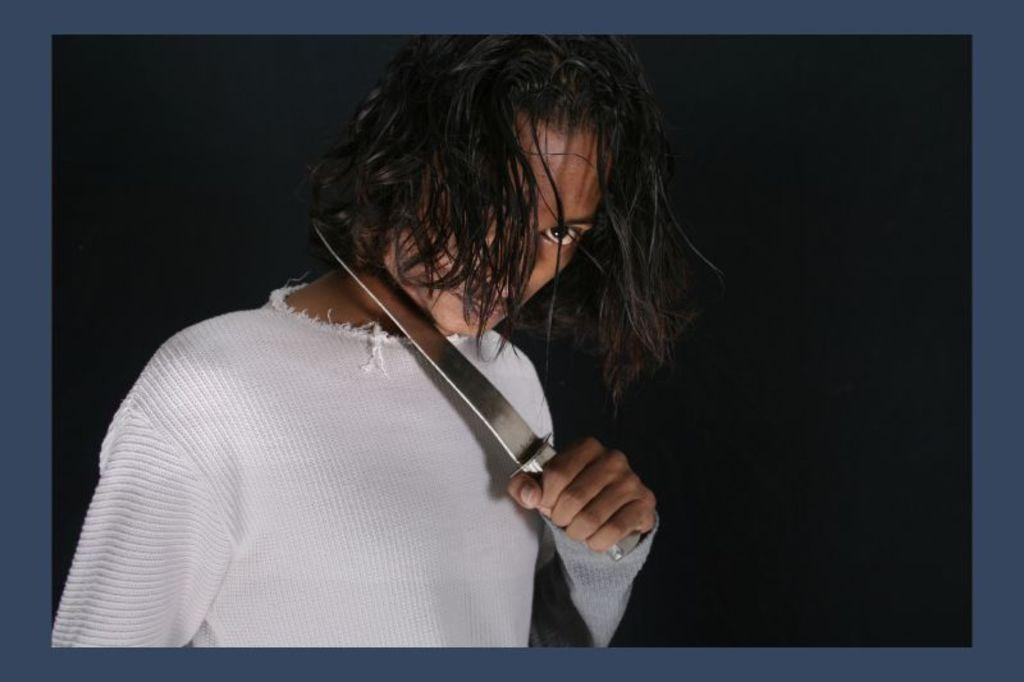What is the main subject of the image? There is a person in the image. What is the person doing in the image? The person is holding a knife near their neck. What color is the background of the image? The background of the image is black. What type of brick is being used to express shame in the image? There is no brick or expression of shame present in the image. 